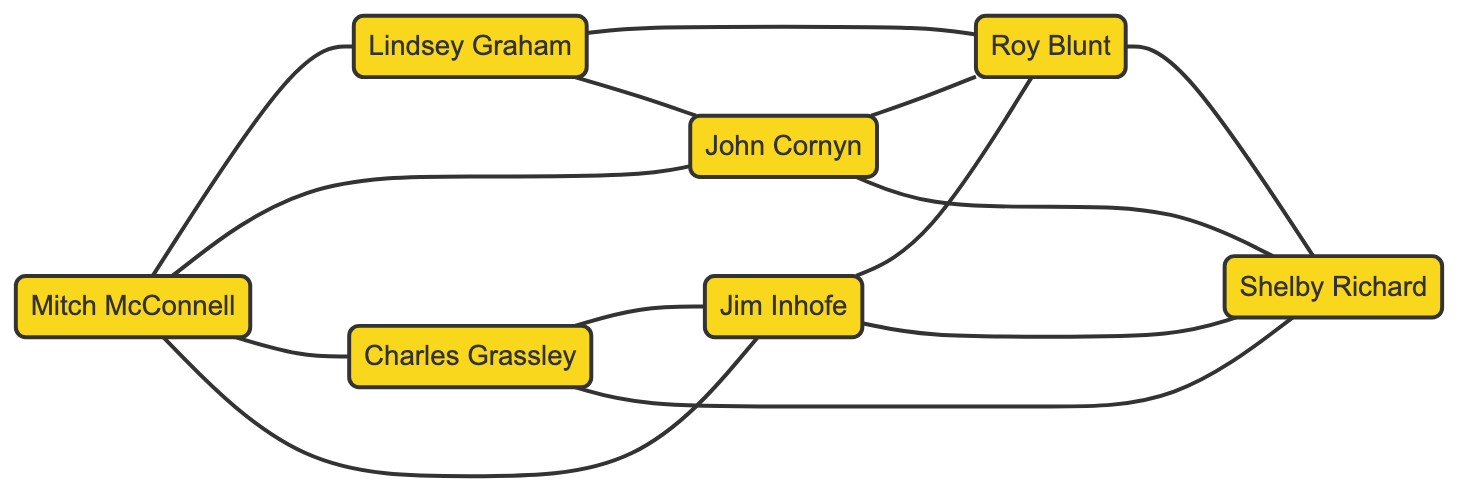What is the total number of legislators in the graph? The graph lists 7 nodes, each representing a legislator: Mitch McConnell, Lindsey Graham, Charles Grassley, John Cornyn, Roy Blunt, Jim Inhofe, and Shelby Richard. Therefore, the total number is 7.
Answer: 7 Which two legislators have a direct connection represented by an edge? The question explores the connections represented in the edges. One example from the edges is the connection between Mitch McConnell and Lindsey Graham, indicating they have a direct connection.
Answer: Mitch McConnell and Lindsey Graham How many edges connect Jim Inhofe to other legislators? By analyzing the connections of Jim Inhofe in the edges, he is connected to Roy Blunt, John Cornyn, Mitch McConnell, and Shelby Richard. This results in a total of 4 edges.
Answer: 4 Who is connected to both John Cornyn and Roy Blunt? To find a common connection to both legislators, I check the edges. Lindsey Graham connects to John Cornyn and also connects to Roy Blunt, making him the answer.
Answer: Lindsey Graham What is the relationship between Charles Grassley and Shelby Richard? Observing the edges, there is a direct connection between Charles Grassley and Shelby Richard, which indicates they share a relationship represented by an edge in the diagram.
Answer: Connected How many edges are in the graph? To find the total number of edges, I count each connection listed in the edges section. There are 12 edges connecting the various legislators.
Answer: 12 Which legislator has the most connections to other senators? Analyzing the edges shows Mitch McConnell is connected to Lindsey Graham, John Cornyn, Charles Grassley, and Jim Inhofe, totaling 4 connections. This makes him the most connected senator in the graph.
Answer: Mitch McConnell Identify a pair of senators that have no direct connection in the graph. By examining the edges, it is possible to find pairs of senators with no direct edge. For instance, Mitch McConnell and Shelby Richard are not directly connected in the graph.
Answer: Mitch McConnell and Shelby Richard How many connections does Roy Blunt have in total? Evaluating the edges, Roy Blunt is connected to Lindsey Graham, Jim Inhofe, John Cornyn, and Shelby Richard, resulting in 4 total connections.
Answer: 4 Which senator shares the most connections with Charles Grassley? Checking the edges, Charles Grassley is directly connected to Jim Inhofe and Shelby Richard. Since he has two direct connections, the answer is either Jim Inhofe or Shelby Richard, both sharing an equal number of connections.
Answer: Jim Inhofe or Shelby Richard 